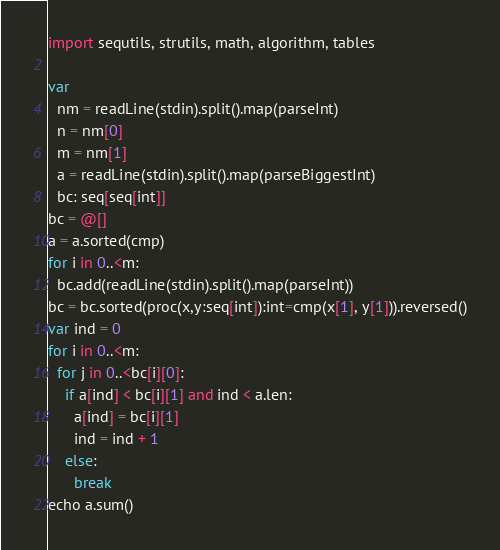<code> <loc_0><loc_0><loc_500><loc_500><_Nim_>import sequtils, strutils, math, algorithm, tables

var
  nm = readLine(stdin).split().map(parseInt)
  n = nm[0]
  m = nm[1]
  a = readLine(stdin).split().map(parseBiggestInt)
  bc: seq[seq[int]]
bc = @[]
a = a.sorted(cmp)
for i in 0..<m:
  bc.add(readLine(stdin).split().map(parseInt))
bc = bc.sorted(proc(x,y:seq[int]):int=cmp(x[1], y[1])).reversed()
var ind = 0
for i in 0..<m:
  for j in 0..<bc[i][0]:
    if a[ind] < bc[i][1] and ind < a.len:
      a[ind] = bc[i][1]
      ind = ind + 1
    else:
      break
echo a.sum()</code> 